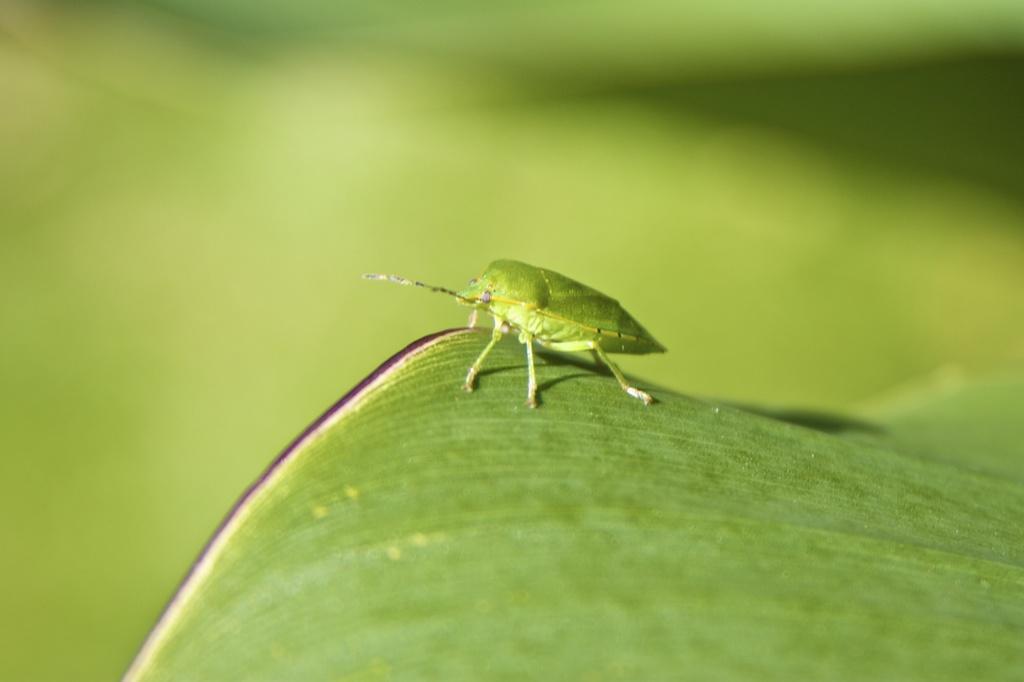Please provide a concise description of this image. In this image we can see a green color bug standing on a green color leaf. 